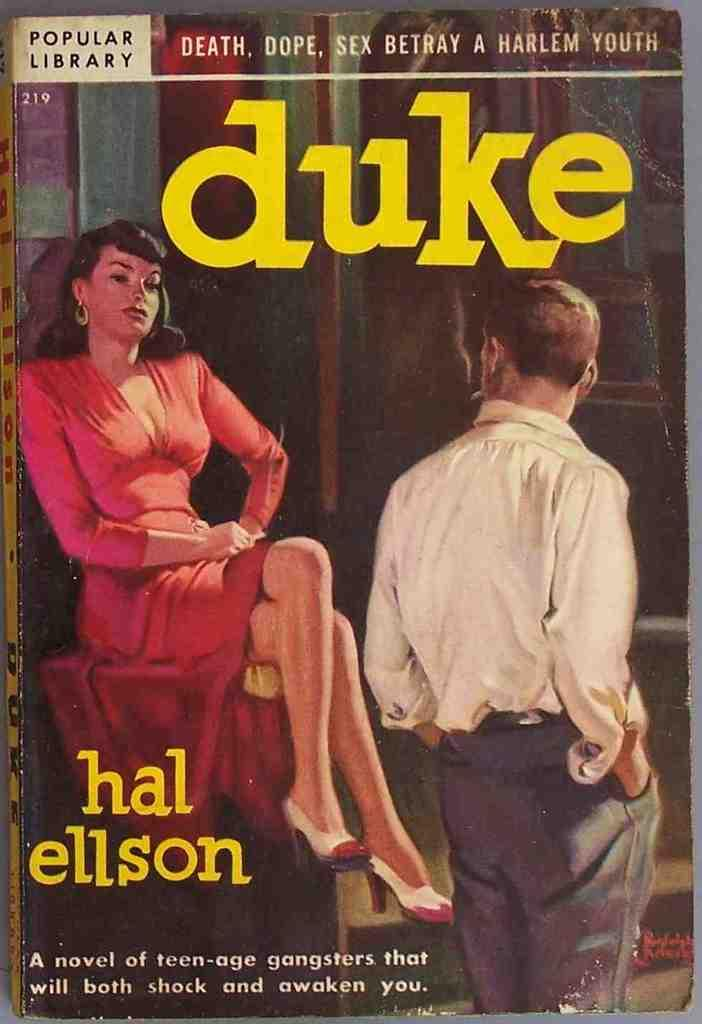<image>
Present a compact description of the photo's key features. A book titled Duke by the author Hal Ellson. 